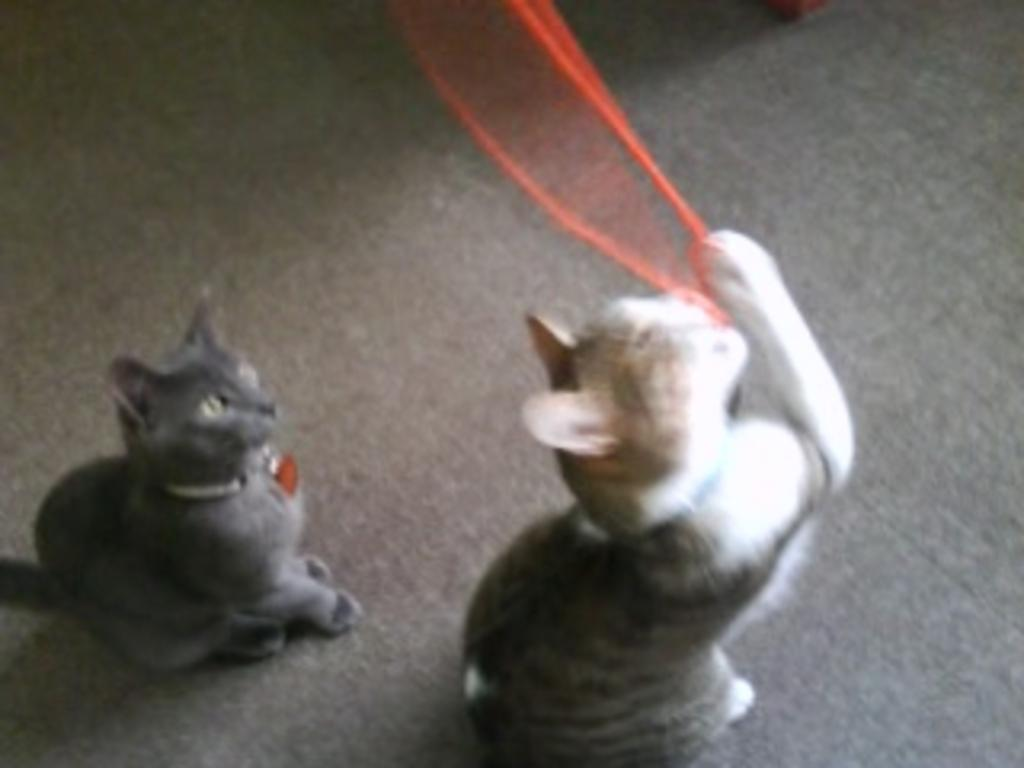How many cats are present in the image? There are two cats in the image. What is the surface on which the cats are standing? The cats are standing on a mat floor. What are the cats doing in the image? The cats are playing. What type of fruit can be seen growing on the tree in the image? There is no tree or fruit present in the image; it features two cats playing on a mat floor. What is the cats using to open the jar in the image? There is no jar present in the image. 